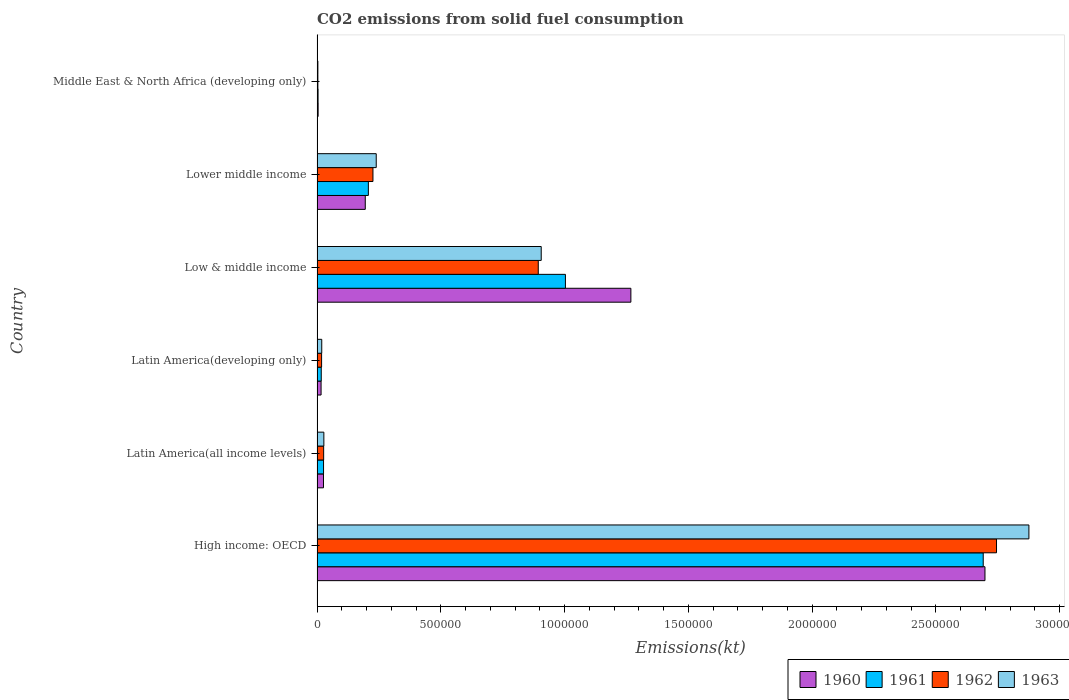How many different coloured bars are there?
Your response must be concise. 4. How many bars are there on the 6th tick from the top?
Offer a terse response. 4. How many bars are there on the 5th tick from the bottom?
Keep it short and to the point. 4. What is the label of the 2nd group of bars from the top?
Keep it short and to the point. Lower middle income. What is the amount of CO2 emitted in 1961 in Middle East & North Africa (developing only)?
Your answer should be very brief. 4102.45. Across all countries, what is the maximum amount of CO2 emitted in 1963?
Give a very brief answer. 2.88e+06. Across all countries, what is the minimum amount of CO2 emitted in 1961?
Your answer should be compact. 4102.45. In which country was the amount of CO2 emitted in 1963 maximum?
Your response must be concise. High income: OECD. In which country was the amount of CO2 emitted in 1963 minimum?
Ensure brevity in your answer.  Middle East & North Africa (developing only). What is the total amount of CO2 emitted in 1960 in the graph?
Your response must be concise. 4.21e+06. What is the difference between the amount of CO2 emitted in 1960 in Latin America(developing only) and that in Middle East & North Africa (developing only)?
Make the answer very short. 1.19e+04. What is the difference between the amount of CO2 emitted in 1960 in High income: OECD and the amount of CO2 emitted in 1963 in Low & middle income?
Keep it short and to the point. 1.79e+06. What is the average amount of CO2 emitted in 1960 per country?
Your answer should be compact. 7.01e+05. What is the difference between the amount of CO2 emitted in 1962 and amount of CO2 emitted in 1960 in Latin America(developing only)?
Ensure brevity in your answer.  2101.12. What is the ratio of the amount of CO2 emitted in 1960 in High income: OECD to that in Latin America(developing only)?
Keep it short and to the point. 166.07. Is the amount of CO2 emitted in 1961 in Low & middle income less than that in Middle East & North Africa (developing only)?
Provide a short and direct response. No. What is the difference between the highest and the second highest amount of CO2 emitted in 1963?
Give a very brief answer. 1.97e+06. What is the difference between the highest and the lowest amount of CO2 emitted in 1962?
Provide a short and direct response. 2.74e+06. In how many countries, is the amount of CO2 emitted in 1960 greater than the average amount of CO2 emitted in 1960 taken over all countries?
Provide a short and direct response. 2. What does the 4th bar from the top in Middle East & North Africa (developing only) represents?
Make the answer very short. 1960. What does the 4th bar from the bottom in Middle East & North Africa (developing only) represents?
Offer a terse response. 1963. Is it the case that in every country, the sum of the amount of CO2 emitted in 1961 and amount of CO2 emitted in 1962 is greater than the amount of CO2 emitted in 1960?
Your answer should be very brief. Yes. How many bars are there?
Your answer should be compact. 24. How many countries are there in the graph?
Provide a short and direct response. 6. What is the difference between two consecutive major ticks on the X-axis?
Your response must be concise. 5.00e+05. Are the values on the major ticks of X-axis written in scientific E-notation?
Offer a terse response. No. Does the graph contain grids?
Ensure brevity in your answer.  No. Where does the legend appear in the graph?
Offer a very short reply. Bottom right. What is the title of the graph?
Make the answer very short. CO2 emissions from solid fuel consumption. What is the label or title of the X-axis?
Your answer should be very brief. Emissions(kt). What is the label or title of the Y-axis?
Keep it short and to the point. Country. What is the Emissions(kt) of 1960 in High income: OECD?
Provide a short and direct response. 2.70e+06. What is the Emissions(kt) of 1961 in High income: OECD?
Your answer should be compact. 2.69e+06. What is the Emissions(kt) in 1962 in High income: OECD?
Offer a terse response. 2.75e+06. What is the Emissions(kt) of 1963 in High income: OECD?
Keep it short and to the point. 2.88e+06. What is the Emissions(kt) in 1960 in Latin America(all income levels)?
Make the answer very short. 2.60e+04. What is the Emissions(kt) of 1961 in Latin America(all income levels)?
Give a very brief answer. 2.63e+04. What is the Emissions(kt) in 1962 in Latin America(all income levels)?
Your response must be concise. 2.67e+04. What is the Emissions(kt) in 1963 in Latin America(all income levels)?
Your answer should be very brief. 2.75e+04. What is the Emissions(kt) in 1960 in Latin America(developing only)?
Make the answer very short. 1.62e+04. What is the Emissions(kt) in 1961 in Latin America(developing only)?
Your response must be concise. 1.70e+04. What is the Emissions(kt) of 1962 in Latin America(developing only)?
Your answer should be very brief. 1.83e+04. What is the Emissions(kt) in 1963 in Latin America(developing only)?
Offer a very short reply. 1.90e+04. What is the Emissions(kt) in 1960 in Low & middle income?
Make the answer very short. 1.27e+06. What is the Emissions(kt) of 1961 in Low & middle income?
Provide a succinct answer. 1.00e+06. What is the Emissions(kt) in 1962 in Low & middle income?
Offer a terse response. 8.94e+05. What is the Emissions(kt) in 1963 in Low & middle income?
Your answer should be very brief. 9.06e+05. What is the Emissions(kt) of 1960 in Lower middle income?
Make the answer very short. 1.95e+05. What is the Emissions(kt) in 1961 in Lower middle income?
Your response must be concise. 2.07e+05. What is the Emissions(kt) of 1962 in Lower middle income?
Give a very brief answer. 2.26e+05. What is the Emissions(kt) of 1963 in Lower middle income?
Make the answer very short. 2.39e+05. What is the Emissions(kt) of 1960 in Middle East & North Africa (developing only)?
Your answer should be very brief. 4356.8. What is the Emissions(kt) of 1961 in Middle East & North Africa (developing only)?
Provide a succinct answer. 4102.45. What is the Emissions(kt) in 1962 in Middle East & North Africa (developing only)?
Your answer should be compact. 3311.16. What is the Emissions(kt) of 1963 in Middle East & North Africa (developing only)?
Your response must be concise. 3301.74. Across all countries, what is the maximum Emissions(kt) in 1960?
Give a very brief answer. 2.70e+06. Across all countries, what is the maximum Emissions(kt) of 1961?
Keep it short and to the point. 2.69e+06. Across all countries, what is the maximum Emissions(kt) of 1962?
Your answer should be very brief. 2.75e+06. Across all countries, what is the maximum Emissions(kt) of 1963?
Offer a terse response. 2.88e+06. Across all countries, what is the minimum Emissions(kt) of 1960?
Keep it short and to the point. 4356.8. Across all countries, what is the minimum Emissions(kt) of 1961?
Keep it short and to the point. 4102.45. Across all countries, what is the minimum Emissions(kt) in 1962?
Offer a terse response. 3311.16. Across all countries, what is the minimum Emissions(kt) in 1963?
Your answer should be very brief. 3301.74. What is the total Emissions(kt) in 1960 in the graph?
Your answer should be very brief. 4.21e+06. What is the total Emissions(kt) in 1961 in the graph?
Ensure brevity in your answer.  3.95e+06. What is the total Emissions(kt) of 1962 in the graph?
Offer a terse response. 3.91e+06. What is the total Emissions(kt) of 1963 in the graph?
Your answer should be compact. 4.07e+06. What is the difference between the Emissions(kt) in 1960 in High income: OECD and that in Latin America(all income levels)?
Make the answer very short. 2.67e+06. What is the difference between the Emissions(kt) of 1961 in High income: OECD and that in Latin America(all income levels)?
Your answer should be very brief. 2.67e+06. What is the difference between the Emissions(kt) of 1962 in High income: OECD and that in Latin America(all income levels)?
Offer a very short reply. 2.72e+06. What is the difference between the Emissions(kt) of 1963 in High income: OECD and that in Latin America(all income levels)?
Offer a terse response. 2.85e+06. What is the difference between the Emissions(kt) of 1960 in High income: OECD and that in Latin America(developing only)?
Give a very brief answer. 2.68e+06. What is the difference between the Emissions(kt) in 1961 in High income: OECD and that in Latin America(developing only)?
Your response must be concise. 2.67e+06. What is the difference between the Emissions(kt) of 1962 in High income: OECD and that in Latin America(developing only)?
Give a very brief answer. 2.73e+06. What is the difference between the Emissions(kt) in 1963 in High income: OECD and that in Latin America(developing only)?
Your answer should be very brief. 2.86e+06. What is the difference between the Emissions(kt) of 1960 in High income: OECD and that in Low & middle income?
Your answer should be very brief. 1.43e+06. What is the difference between the Emissions(kt) in 1961 in High income: OECD and that in Low & middle income?
Ensure brevity in your answer.  1.69e+06. What is the difference between the Emissions(kt) in 1962 in High income: OECD and that in Low & middle income?
Your answer should be compact. 1.85e+06. What is the difference between the Emissions(kt) of 1963 in High income: OECD and that in Low & middle income?
Offer a very short reply. 1.97e+06. What is the difference between the Emissions(kt) in 1960 in High income: OECD and that in Lower middle income?
Your response must be concise. 2.50e+06. What is the difference between the Emissions(kt) of 1961 in High income: OECD and that in Lower middle income?
Offer a terse response. 2.48e+06. What is the difference between the Emissions(kt) of 1962 in High income: OECD and that in Lower middle income?
Keep it short and to the point. 2.52e+06. What is the difference between the Emissions(kt) in 1963 in High income: OECD and that in Lower middle income?
Your answer should be very brief. 2.64e+06. What is the difference between the Emissions(kt) of 1960 in High income: OECD and that in Middle East & North Africa (developing only)?
Offer a very short reply. 2.69e+06. What is the difference between the Emissions(kt) of 1961 in High income: OECD and that in Middle East & North Africa (developing only)?
Provide a short and direct response. 2.69e+06. What is the difference between the Emissions(kt) of 1962 in High income: OECD and that in Middle East & North Africa (developing only)?
Provide a short and direct response. 2.74e+06. What is the difference between the Emissions(kt) of 1963 in High income: OECD and that in Middle East & North Africa (developing only)?
Provide a succinct answer. 2.87e+06. What is the difference between the Emissions(kt) of 1960 in Latin America(all income levels) and that in Latin America(developing only)?
Make the answer very short. 9759.8. What is the difference between the Emissions(kt) of 1961 in Latin America(all income levels) and that in Latin America(developing only)?
Give a very brief answer. 9282.45. What is the difference between the Emissions(kt) in 1962 in Latin America(all income levels) and that in Latin America(developing only)?
Ensure brevity in your answer.  8301.83. What is the difference between the Emissions(kt) of 1963 in Latin America(all income levels) and that in Latin America(developing only)?
Provide a succinct answer. 8542.91. What is the difference between the Emissions(kt) in 1960 in Latin America(all income levels) and that in Low & middle income?
Make the answer very short. -1.24e+06. What is the difference between the Emissions(kt) in 1961 in Latin America(all income levels) and that in Low & middle income?
Your response must be concise. -9.77e+05. What is the difference between the Emissions(kt) of 1962 in Latin America(all income levels) and that in Low & middle income?
Keep it short and to the point. -8.67e+05. What is the difference between the Emissions(kt) of 1963 in Latin America(all income levels) and that in Low & middle income?
Your answer should be very brief. -8.78e+05. What is the difference between the Emissions(kt) of 1960 in Latin America(all income levels) and that in Lower middle income?
Your answer should be compact. -1.69e+05. What is the difference between the Emissions(kt) of 1961 in Latin America(all income levels) and that in Lower middle income?
Provide a succinct answer. -1.81e+05. What is the difference between the Emissions(kt) in 1962 in Latin America(all income levels) and that in Lower middle income?
Keep it short and to the point. -1.99e+05. What is the difference between the Emissions(kt) of 1963 in Latin America(all income levels) and that in Lower middle income?
Provide a succinct answer. -2.12e+05. What is the difference between the Emissions(kt) in 1960 in Latin America(all income levels) and that in Middle East & North Africa (developing only)?
Provide a short and direct response. 2.17e+04. What is the difference between the Emissions(kt) in 1961 in Latin America(all income levels) and that in Middle East & North Africa (developing only)?
Keep it short and to the point. 2.22e+04. What is the difference between the Emissions(kt) in 1962 in Latin America(all income levels) and that in Middle East & North Africa (developing only)?
Keep it short and to the point. 2.33e+04. What is the difference between the Emissions(kt) of 1963 in Latin America(all income levels) and that in Middle East & North Africa (developing only)?
Ensure brevity in your answer.  2.42e+04. What is the difference between the Emissions(kt) in 1960 in Latin America(developing only) and that in Low & middle income?
Your answer should be very brief. -1.25e+06. What is the difference between the Emissions(kt) of 1961 in Latin America(developing only) and that in Low & middle income?
Make the answer very short. -9.86e+05. What is the difference between the Emissions(kt) of 1962 in Latin America(developing only) and that in Low & middle income?
Offer a very short reply. -8.75e+05. What is the difference between the Emissions(kt) of 1963 in Latin America(developing only) and that in Low & middle income?
Keep it short and to the point. -8.87e+05. What is the difference between the Emissions(kt) in 1960 in Latin America(developing only) and that in Lower middle income?
Your response must be concise. -1.79e+05. What is the difference between the Emissions(kt) in 1961 in Latin America(developing only) and that in Lower middle income?
Provide a succinct answer. -1.90e+05. What is the difference between the Emissions(kt) of 1962 in Latin America(developing only) and that in Lower middle income?
Provide a short and direct response. -2.08e+05. What is the difference between the Emissions(kt) in 1963 in Latin America(developing only) and that in Lower middle income?
Your answer should be very brief. -2.20e+05. What is the difference between the Emissions(kt) in 1960 in Latin America(developing only) and that in Middle East & North Africa (developing only)?
Keep it short and to the point. 1.19e+04. What is the difference between the Emissions(kt) of 1961 in Latin America(developing only) and that in Middle East & North Africa (developing only)?
Make the answer very short. 1.29e+04. What is the difference between the Emissions(kt) of 1962 in Latin America(developing only) and that in Middle East & North Africa (developing only)?
Your answer should be very brief. 1.50e+04. What is the difference between the Emissions(kt) in 1963 in Latin America(developing only) and that in Middle East & North Africa (developing only)?
Provide a short and direct response. 1.57e+04. What is the difference between the Emissions(kt) in 1960 in Low & middle income and that in Lower middle income?
Your response must be concise. 1.07e+06. What is the difference between the Emissions(kt) of 1961 in Low & middle income and that in Lower middle income?
Offer a terse response. 7.96e+05. What is the difference between the Emissions(kt) in 1962 in Low & middle income and that in Lower middle income?
Offer a terse response. 6.68e+05. What is the difference between the Emissions(kt) of 1963 in Low & middle income and that in Lower middle income?
Provide a short and direct response. 6.67e+05. What is the difference between the Emissions(kt) in 1960 in Low & middle income and that in Middle East & North Africa (developing only)?
Provide a short and direct response. 1.26e+06. What is the difference between the Emissions(kt) of 1961 in Low & middle income and that in Middle East & North Africa (developing only)?
Provide a succinct answer. 9.99e+05. What is the difference between the Emissions(kt) in 1962 in Low & middle income and that in Middle East & North Africa (developing only)?
Your response must be concise. 8.90e+05. What is the difference between the Emissions(kt) of 1963 in Low & middle income and that in Middle East & North Africa (developing only)?
Offer a very short reply. 9.02e+05. What is the difference between the Emissions(kt) in 1960 in Lower middle income and that in Middle East & North Africa (developing only)?
Provide a short and direct response. 1.90e+05. What is the difference between the Emissions(kt) in 1961 in Lower middle income and that in Middle East & North Africa (developing only)?
Your answer should be compact. 2.03e+05. What is the difference between the Emissions(kt) of 1962 in Lower middle income and that in Middle East & North Africa (developing only)?
Provide a short and direct response. 2.23e+05. What is the difference between the Emissions(kt) in 1963 in Lower middle income and that in Middle East & North Africa (developing only)?
Your response must be concise. 2.36e+05. What is the difference between the Emissions(kt) in 1960 in High income: OECD and the Emissions(kt) in 1961 in Latin America(all income levels)?
Ensure brevity in your answer.  2.67e+06. What is the difference between the Emissions(kt) in 1960 in High income: OECD and the Emissions(kt) in 1962 in Latin America(all income levels)?
Provide a short and direct response. 2.67e+06. What is the difference between the Emissions(kt) of 1960 in High income: OECD and the Emissions(kt) of 1963 in Latin America(all income levels)?
Keep it short and to the point. 2.67e+06. What is the difference between the Emissions(kt) of 1961 in High income: OECD and the Emissions(kt) of 1962 in Latin America(all income levels)?
Make the answer very short. 2.66e+06. What is the difference between the Emissions(kt) of 1961 in High income: OECD and the Emissions(kt) of 1963 in Latin America(all income levels)?
Keep it short and to the point. 2.66e+06. What is the difference between the Emissions(kt) of 1962 in High income: OECD and the Emissions(kt) of 1963 in Latin America(all income levels)?
Ensure brevity in your answer.  2.72e+06. What is the difference between the Emissions(kt) of 1960 in High income: OECD and the Emissions(kt) of 1961 in Latin America(developing only)?
Provide a succinct answer. 2.68e+06. What is the difference between the Emissions(kt) of 1960 in High income: OECD and the Emissions(kt) of 1962 in Latin America(developing only)?
Ensure brevity in your answer.  2.68e+06. What is the difference between the Emissions(kt) of 1960 in High income: OECD and the Emissions(kt) of 1963 in Latin America(developing only)?
Your answer should be very brief. 2.68e+06. What is the difference between the Emissions(kt) in 1961 in High income: OECD and the Emissions(kt) in 1962 in Latin America(developing only)?
Offer a very short reply. 2.67e+06. What is the difference between the Emissions(kt) in 1961 in High income: OECD and the Emissions(kt) in 1963 in Latin America(developing only)?
Your answer should be compact. 2.67e+06. What is the difference between the Emissions(kt) in 1962 in High income: OECD and the Emissions(kt) in 1963 in Latin America(developing only)?
Ensure brevity in your answer.  2.73e+06. What is the difference between the Emissions(kt) of 1960 in High income: OECD and the Emissions(kt) of 1961 in Low & middle income?
Ensure brevity in your answer.  1.69e+06. What is the difference between the Emissions(kt) of 1960 in High income: OECD and the Emissions(kt) of 1962 in Low & middle income?
Offer a very short reply. 1.80e+06. What is the difference between the Emissions(kt) of 1960 in High income: OECD and the Emissions(kt) of 1963 in Low & middle income?
Give a very brief answer. 1.79e+06. What is the difference between the Emissions(kt) of 1961 in High income: OECD and the Emissions(kt) of 1962 in Low & middle income?
Give a very brief answer. 1.80e+06. What is the difference between the Emissions(kt) of 1961 in High income: OECD and the Emissions(kt) of 1963 in Low & middle income?
Provide a succinct answer. 1.79e+06. What is the difference between the Emissions(kt) in 1962 in High income: OECD and the Emissions(kt) in 1963 in Low & middle income?
Provide a short and direct response. 1.84e+06. What is the difference between the Emissions(kt) of 1960 in High income: OECD and the Emissions(kt) of 1961 in Lower middle income?
Offer a very short reply. 2.49e+06. What is the difference between the Emissions(kt) in 1960 in High income: OECD and the Emissions(kt) in 1962 in Lower middle income?
Ensure brevity in your answer.  2.47e+06. What is the difference between the Emissions(kt) in 1960 in High income: OECD and the Emissions(kt) in 1963 in Lower middle income?
Provide a succinct answer. 2.46e+06. What is the difference between the Emissions(kt) of 1961 in High income: OECD and the Emissions(kt) of 1962 in Lower middle income?
Ensure brevity in your answer.  2.47e+06. What is the difference between the Emissions(kt) in 1961 in High income: OECD and the Emissions(kt) in 1963 in Lower middle income?
Your response must be concise. 2.45e+06. What is the difference between the Emissions(kt) in 1962 in High income: OECD and the Emissions(kt) in 1963 in Lower middle income?
Provide a short and direct response. 2.51e+06. What is the difference between the Emissions(kt) in 1960 in High income: OECD and the Emissions(kt) in 1961 in Middle East & North Africa (developing only)?
Provide a short and direct response. 2.69e+06. What is the difference between the Emissions(kt) of 1960 in High income: OECD and the Emissions(kt) of 1962 in Middle East & North Africa (developing only)?
Your answer should be very brief. 2.70e+06. What is the difference between the Emissions(kt) in 1960 in High income: OECD and the Emissions(kt) in 1963 in Middle East & North Africa (developing only)?
Offer a very short reply. 2.70e+06. What is the difference between the Emissions(kt) of 1961 in High income: OECD and the Emissions(kt) of 1962 in Middle East & North Africa (developing only)?
Your answer should be very brief. 2.69e+06. What is the difference between the Emissions(kt) in 1961 in High income: OECD and the Emissions(kt) in 1963 in Middle East & North Africa (developing only)?
Give a very brief answer. 2.69e+06. What is the difference between the Emissions(kt) in 1962 in High income: OECD and the Emissions(kt) in 1963 in Middle East & North Africa (developing only)?
Offer a very short reply. 2.74e+06. What is the difference between the Emissions(kt) of 1960 in Latin America(all income levels) and the Emissions(kt) of 1961 in Latin America(developing only)?
Give a very brief answer. 9031.46. What is the difference between the Emissions(kt) of 1960 in Latin America(all income levels) and the Emissions(kt) of 1962 in Latin America(developing only)?
Make the answer very short. 7658.68. What is the difference between the Emissions(kt) in 1960 in Latin America(all income levels) and the Emissions(kt) in 1963 in Latin America(developing only)?
Provide a succinct answer. 7040.93. What is the difference between the Emissions(kt) in 1961 in Latin America(all income levels) and the Emissions(kt) in 1962 in Latin America(developing only)?
Your answer should be compact. 7909.66. What is the difference between the Emissions(kt) of 1961 in Latin America(all income levels) and the Emissions(kt) of 1963 in Latin America(developing only)?
Offer a very short reply. 7291.91. What is the difference between the Emissions(kt) of 1962 in Latin America(all income levels) and the Emissions(kt) of 1963 in Latin America(developing only)?
Offer a terse response. 7684.07. What is the difference between the Emissions(kt) of 1960 in Latin America(all income levels) and the Emissions(kt) of 1961 in Low & middle income?
Keep it short and to the point. -9.77e+05. What is the difference between the Emissions(kt) of 1960 in Latin America(all income levels) and the Emissions(kt) of 1962 in Low & middle income?
Make the answer very short. -8.68e+05. What is the difference between the Emissions(kt) in 1960 in Latin America(all income levels) and the Emissions(kt) in 1963 in Low & middle income?
Offer a terse response. -8.80e+05. What is the difference between the Emissions(kt) in 1961 in Latin America(all income levels) and the Emissions(kt) in 1962 in Low & middle income?
Keep it short and to the point. -8.67e+05. What is the difference between the Emissions(kt) of 1961 in Latin America(all income levels) and the Emissions(kt) of 1963 in Low & middle income?
Provide a short and direct response. -8.79e+05. What is the difference between the Emissions(kt) in 1962 in Latin America(all income levels) and the Emissions(kt) in 1963 in Low & middle income?
Provide a short and direct response. -8.79e+05. What is the difference between the Emissions(kt) in 1960 in Latin America(all income levels) and the Emissions(kt) in 1961 in Lower middle income?
Your answer should be very brief. -1.81e+05. What is the difference between the Emissions(kt) of 1960 in Latin America(all income levels) and the Emissions(kt) of 1962 in Lower middle income?
Give a very brief answer. -2.00e+05. What is the difference between the Emissions(kt) in 1960 in Latin America(all income levels) and the Emissions(kt) in 1963 in Lower middle income?
Your response must be concise. -2.13e+05. What is the difference between the Emissions(kt) in 1961 in Latin America(all income levels) and the Emissions(kt) in 1962 in Lower middle income?
Make the answer very short. -2.00e+05. What is the difference between the Emissions(kt) of 1961 in Latin America(all income levels) and the Emissions(kt) of 1963 in Lower middle income?
Give a very brief answer. -2.13e+05. What is the difference between the Emissions(kt) of 1962 in Latin America(all income levels) and the Emissions(kt) of 1963 in Lower middle income?
Make the answer very short. -2.12e+05. What is the difference between the Emissions(kt) in 1960 in Latin America(all income levels) and the Emissions(kt) in 1961 in Middle East & North Africa (developing only)?
Make the answer very short. 2.19e+04. What is the difference between the Emissions(kt) in 1960 in Latin America(all income levels) and the Emissions(kt) in 1962 in Middle East & North Africa (developing only)?
Your response must be concise. 2.27e+04. What is the difference between the Emissions(kt) in 1960 in Latin America(all income levels) and the Emissions(kt) in 1963 in Middle East & North Africa (developing only)?
Make the answer very short. 2.27e+04. What is the difference between the Emissions(kt) in 1961 in Latin America(all income levels) and the Emissions(kt) in 1962 in Middle East & North Africa (developing only)?
Your answer should be very brief. 2.29e+04. What is the difference between the Emissions(kt) of 1961 in Latin America(all income levels) and the Emissions(kt) of 1963 in Middle East & North Africa (developing only)?
Provide a succinct answer. 2.30e+04. What is the difference between the Emissions(kt) of 1962 in Latin America(all income levels) and the Emissions(kt) of 1963 in Middle East & North Africa (developing only)?
Ensure brevity in your answer.  2.33e+04. What is the difference between the Emissions(kt) of 1960 in Latin America(developing only) and the Emissions(kt) of 1961 in Low & middle income?
Provide a short and direct response. -9.87e+05. What is the difference between the Emissions(kt) of 1960 in Latin America(developing only) and the Emissions(kt) of 1962 in Low & middle income?
Provide a succinct answer. -8.77e+05. What is the difference between the Emissions(kt) in 1960 in Latin America(developing only) and the Emissions(kt) in 1963 in Low & middle income?
Your response must be concise. -8.89e+05. What is the difference between the Emissions(kt) of 1961 in Latin America(developing only) and the Emissions(kt) of 1962 in Low & middle income?
Provide a short and direct response. -8.77e+05. What is the difference between the Emissions(kt) in 1961 in Latin America(developing only) and the Emissions(kt) in 1963 in Low & middle income?
Give a very brief answer. -8.89e+05. What is the difference between the Emissions(kt) of 1962 in Latin America(developing only) and the Emissions(kt) of 1963 in Low & middle income?
Your response must be concise. -8.87e+05. What is the difference between the Emissions(kt) in 1960 in Latin America(developing only) and the Emissions(kt) in 1961 in Lower middle income?
Provide a succinct answer. -1.91e+05. What is the difference between the Emissions(kt) of 1960 in Latin America(developing only) and the Emissions(kt) of 1962 in Lower middle income?
Provide a short and direct response. -2.10e+05. What is the difference between the Emissions(kt) of 1960 in Latin America(developing only) and the Emissions(kt) of 1963 in Lower middle income?
Your response must be concise. -2.23e+05. What is the difference between the Emissions(kt) of 1961 in Latin America(developing only) and the Emissions(kt) of 1962 in Lower middle income?
Provide a short and direct response. -2.09e+05. What is the difference between the Emissions(kt) of 1961 in Latin America(developing only) and the Emissions(kt) of 1963 in Lower middle income?
Give a very brief answer. -2.22e+05. What is the difference between the Emissions(kt) in 1962 in Latin America(developing only) and the Emissions(kt) in 1963 in Lower middle income?
Offer a terse response. -2.21e+05. What is the difference between the Emissions(kt) in 1960 in Latin America(developing only) and the Emissions(kt) in 1961 in Middle East & North Africa (developing only)?
Offer a very short reply. 1.21e+04. What is the difference between the Emissions(kt) in 1960 in Latin America(developing only) and the Emissions(kt) in 1962 in Middle East & North Africa (developing only)?
Keep it short and to the point. 1.29e+04. What is the difference between the Emissions(kt) in 1960 in Latin America(developing only) and the Emissions(kt) in 1963 in Middle East & North Africa (developing only)?
Offer a very short reply. 1.29e+04. What is the difference between the Emissions(kt) of 1961 in Latin America(developing only) and the Emissions(kt) of 1962 in Middle East & North Africa (developing only)?
Ensure brevity in your answer.  1.37e+04. What is the difference between the Emissions(kt) of 1961 in Latin America(developing only) and the Emissions(kt) of 1963 in Middle East & North Africa (developing only)?
Offer a very short reply. 1.37e+04. What is the difference between the Emissions(kt) of 1962 in Latin America(developing only) and the Emissions(kt) of 1963 in Middle East & North Africa (developing only)?
Your answer should be very brief. 1.50e+04. What is the difference between the Emissions(kt) of 1960 in Low & middle income and the Emissions(kt) of 1961 in Lower middle income?
Your answer should be very brief. 1.06e+06. What is the difference between the Emissions(kt) in 1960 in Low & middle income and the Emissions(kt) in 1962 in Lower middle income?
Offer a very short reply. 1.04e+06. What is the difference between the Emissions(kt) in 1960 in Low & middle income and the Emissions(kt) in 1963 in Lower middle income?
Offer a terse response. 1.03e+06. What is the difference between the Emissions(kt) in 1961 in Low & middle income and the Emissions(kt) in 1962 in Lower middle income?
Ensure brevity in your answer.  7.78e+05. What is the difference between the Emissions(kt) in 1961 in Low & middle income and the Emissions(kt) in 1963 in Lower middle income?
Ensure brevity in your answer.  7.64e+05. What is the difference between the Emissions(kt) in 1962 in Low & middle income and the Emissions(kt) in 1963 in Lower middle income?
Your response must be concise. 6.55e+05. What is the difference between the Emissions(kt) of 1960 in Low & middle income and the Emissions(kt) of 1961 in Middle East & North Africa (developing only)?
Keep it short and to the point. 1.26e+06. What is the difference between the Emissions(kt) of 1960 in Low & middle income and the Emissions(kt) of 1962 in Middle East & North Africa (developing only)?
Your answer should be very brief. 1.26e+06. What is the difference between the Emissions(kt) of 1960 in Low & middle income and the Emissions(kt) of 1963 in Middle East & North Africa (developing only)?
Provide a succinct answer. 1.26e+06. What is the difference between the Emissions(kt) of 1961 in Low & middle income and the Emissions(kt) of 1962 in Middle East & North Africa (developing only)?
Offer a very short reply. 1.00e+06. What is the difference between the Emissions(kt) of 1961 in Low & middle income and the Emissions(kt) of 1963 in Middle East & North Africa (developing only)?
Give a very brief answer. 1.00e+06. What is the difference between the Emissions(kt) in 1962 in Low & middle income and the Emissions(kt) in 1963 in Middle East & North Africa (developing only)?
Offer a terse response. 8.90e+05. What is the difference between the Emissions(kt) of 1960 in Lower middle income and the Emissions(kt) of 1961 in Middle East & North Africa (developing only)?
Offer a terse response. 1.91e+05. What is the difference between the Emissions(kt) of 1960 in Lower middle income and the Emissions(kt) of 1962 in Middle East & North Africa (developing only)?
Offer a very short reply. 1.91e+05. What is the difference between the Emissions(kt) in 1960 in Lower middle income and the Emissions(kt) in 1963 in Middle East & North Africa (developing only)?
Your answer should be compact. 1.92e+05. What is the difference between the Emissions(kt) in 1961 in Lower middle income and the Emissions(kt) in 1962 in Middle East & North Africa (developing only)?
Offer a terse response. 2.04e+05. What is the difference between the Emissions(kt) of 1961 in Lower middle income and the Emissions(kt) of 1963 in Middle East & North Africa (developing only)?
Provide a succinct answer. 2.04e+05. What is the difference between the Emissions(kt) in 1962 in Lower middle income and the Emissions(kt) in 1963 in Middle East & North Africa (developing only)?
Your answer should be compact. 2.23e+05. What is the average Emissions(kt) in 1960 per country?
Provide a succinct answer. 7.01e+05. What is the average Emissions(kt) in 1961 per country?
Your answer should be very brief. 6.58e+05. What is the average Emissions(kt) in 1962 per country?
Keep it short and to the point. 6.52e+05. What is the average Emissions(kt) in 1963 per country?
Your answer should be compact. 6.78e+05. What is the difference between the Emissions(kt) in 1960 and Emissions(kt) in 1961 in High income: OECD?
Offer a very short reply. 7090.26. What is the difference between the Emissions(kt) in 1960 and Emissions(kt) in 1962 in High income: OECD?
Give a very brief answer. -4.67e+04. What is the difference between the Emissions(kt) in 1960 and Emissions(kt) in 1963 in High income: OECD?
Your answer should be very brief. -1.77e+05. What is the difference between the Emissions(kt) of 1961 and Emissions(kt) of 1962 in High income: OECD?
Offer a very short reply. -5.38e+04. What is the difference between the Emissions(kt) of 1961 and Emissions(kt) of 1963 in High income: OECD?
Ensure brevity in your answer.  -1.85e+05. What is the difference between the Emissions(kt) of 1962 and Emissions(kt) of 1963 in High income: OECD?
Give a very brief answer. -1.31e+05. What is the difference between the Emissions(kt) in 1960 and Emissions(kt) in 1961 in Latin America(all income levels)?
Provide a short and direct response. -250.98. What is the difference between the Emissions(kt) in 1960 and Emissions(kt) in 1962 in Latin America(all income levels)?
Provide a short and direct response. -643.15. What is the difference between the Emissions(kt) of 1960 and Emissions(kt) of 1963 in Latin America(all income levels)?
Keep it short and to the point. -1501.98. What is the difference between the Emissions(kt) in 1961 and Emissions(kt) in 1962 in Latin America(all income levels)?
Your response must be concise. -392.16. What is the difference between the Emissions(kt) in 1961 and Emissions(kt) in 1963 in Latin America(all income levels)?
Ensure brevity in your answer.  -1251. What is the difference between the Emissions(kt) of 1962 and Emissions(kt) of 1963 in Latin America(all income levels)?
Provide a succinct answer. -858.84. What is the difference between the Emissions(kt) in 1960 and Emissions(kt) in 1961 in Latin America(developing only)?
Your answer should be very brief. -728.34. What is the difference between the Emissions(kt) in 1960 and Emissions(kt) in 1962 in Latin America(developing only)?
Make the answer very short. -2101.12. What is the difference between the Emissions(kt) in 1960 and Emissions(kt) in 1963 in Latin America(developing only)?
Provide a succinct answer. -2718.88. What is the difference between the Emissions(kt) in 1961 and Emissions(kt) in 1962 in Latin America(developing only)?
Ensure brevity in your answer.  -1372.79. What is the difference between the Emissions(kt) in 1961 and Emissions(kt) in 1963 in Latin America(developing only)?
Your answer should be very brief. -1990.54. What is the difference between the Emissions(kt) in 1962 and Emissions(kt) in 1963 in Latin America(developing only)?
Give a very brief answer. -617.75. What is the difference between the Emissions(kt) of 1960 and Emissions(kt) of 1961 in Low & middle income?
Your response must be concise. 2.64e+05. What is the difference between the Emissions(kt) in 1960 and Emissions(kt) in 1962 in Low & middle income?
Make the answer very short. 3.74e+05. What is the difference between the Emissions(kt) in 1960 and Emissions(kt) in 1963 in Low & middle income?
Your answer should be compact. 3.62e+05. What is the difference between the Emissions(kt) of 1961 and Emissions(kt) of 1962 in Low & middle income?
Offer a very short reply. 1.10e+05. What is the difference between the Emissions(kt) in 1961 and Emissions(kt) in 1963 in Low & middle income?
Provide a succinct answer. 9.78e+04. What is the difference between the Emissions(kt) of 1962 and Emissions(kt) of 1963 in Low & middle income?
Your response must be concise. -1.20e+04. What is the difference between the Emissions(kt) in 1960 and Emissions(kt) in 1961 in Lower middle income?
Keep it short and to the point. -1.25e+04. What is the difference between the Emissions(kt) in 1960 and Emissions(kt) in 1962 in Lower middle income?
Provide a short and direct response. -3.10e+04. What is the difference between the Emissions(kt) of 1960 and Emissions(kt) of 1963 in Lower middle income?
Your answer should be very brief. -4.43e+04. What is the difference between the Emissions(kt) of 1961 and Emissions(kt) of 1962 in Lower middle income?
Offer a terse response. -1.86e+04. What is the difference between the Emissions(kt) in 1961 and Emissions(kt) in 1963 in Lower middle income?
Your answer should be compact. -3.18e+04. What is the difference between the Emissions(kt) of 1962 and Emissions(kt) of 1963 in Lower middle income?
Provide a succinct answer. -1.32e+04. What is the difference between the Emissions(kt) in 1960 and Emissions(kt) in 1961 in Middle East & North Africa (developing only)?
Your answer should be compact. 254.34. What is the difference between the Emissions(kt) of 1960 and Emissions(kt) of 1962 in Middle East & North Africa (developing only)?
Give a very brief answer. 1045.63. What is the difference between the Emissions(kt) in 1960 and Emissions(kt) in 1963 in Middle East & North Africa (developing only)?
Provide a succinct answer. 1055.05. What is the difference between the Emissions(kt) of 1961 and Emissions(kt) of 1962 in Middle East & North Africa (developing only)?
Ensure brevity in your answer.  791.29. What is the difference between the Emissions(kt) in 1961 and Emissions(kt) in 1963 in Middle East & North Africa (developing only)?
Your answer should be compact. 800.71. What is the difference between the Emissions(kt) in 1962 and Emissions(kt) in 1963 in Middle East & North Africa (developing only)?
Your response must be concise. 9.42. What is the ratio of the Emissions(kt) in 1960 in High income: OECD to that in Latin America(all income levels)?
Provide a short and direct response. 103.75. What is the ratio of the Emissions(kt) of 1961 in High income: OECD to that in Latin America(all income levels)?
Provide a short and direct response. 102.49. What is the ratio of the Emissions(kt) in 1962 in High income: OECD to that in Latin America(all income levels)?
Give a very brief answer. 103. What is the ratio of the Emissions(kt) of 1963 in High income: OECD to that in Latin America(all income levels)?
Offer a very short reply. 104.54. What is the ratio of the Emissions(kt) in 1960 in High income: OECD to that in Latin America(developing only)?
Keep it short and to the point. 166.07. What is the ratio of the Emissions(kt) of 1961 in High income: OECD to that in Latin America(developing only)?
Keep it short and to the point. 158.53. What is the ratio of the Emissions(kt) in 1962 in High income: OECD to that in Latin America(developing only)?
Give a very brief answer. 149.6. What is the ratio of the Emissions(kt) of 1963 in High income: OECD to that in Latin America(developing only)?
Your answer should be compact. 151.62. What is the ratio of the Emissions(kt) of 1960 in High income: OECD to that in Low & middle income?
Your response must be concise. 2.13. What is the ratio of the Emissions(kt) in 1961 in High income: OECD to that in Low & middle income?
Offer a terse response. 2.68. What is the ratio of the Emissions(kt) in 1962 in High income: OECD to that in Low & middle income?
Give a very brief answer. 3.07. What is the ratio of the Emissions(kt) in 1963 in High income: OECD to that in Low & middle income?
Make the answer very short. 3.18. What is the ratio of the Emissions(kt) in 1960 in High income: OECD to that in Lower middle income?
Your answer should be compact. 13.85. What is the ratio of the Emissions(kt) of 1961 in High income: OECD to that in Lower middle income?
Provide a short and direct response. 12.98. What is the ratio of the Emissions(kt) in 1962 in High income: OECD to that in Lower middle income?
Ensure brevity in your answer.  12.15. What is the ratio of the Emissions(kt) of 1963 in High income: OECD to that in Lower middle income?
Provide a short and direct response. 12.03. What is the ratio of the Emissions(kt) of 1960 in High income: OECD to that in Middle East & North Africa (developing only)?
Provide a short and direct response. 619.35. What is the ratio of the Emissions(kt) in 1961 in High income: OECD to that in Middle East & North Africa (developing only)?
Your answer should be very brief. 656.02. What is the ratio of the Emissions(kt) in 1962 in High income: OECD to that in Middle East & North Africa (developing only)?
Provide a short and direct response. 829.03. What is the ratio of the Emissions(kt) in 1963 in High income: OECD to that in Middle East & North Africa (developing only)?
Keep it short and to the point. 871.02. What is the ratio of the Emissions(kt) in 1960 in Latin America(all income levels) to that in Latin America(developing only)?
Your answer should be compact. 1.6. What is the ratio of the Emissions(kt) in 1961 in Latin America(all income levels) to that in Latin America(developing only)?
Offer a very short reply. 1.55. What is the ratio of the Emissions(kt) in 1962 in Latin America(all income levels) to that in Latin America(developing only)?
Offer a very short reply. 1.45. What is the ratio of the Emissions(kt) of 1963 in Latin America(all income levels) to that in Latin America(developing only)?
Provide a succinct answer. 1.45. What is the ratio of the Emissions(kt) of 1960 in Latin America(all income levels) to that in Low & middle income?
Provide a succinct answer. 0.02. What is the ratio of the Emissions(kt) of 1961 in Latin America(all income levels) to that in Low & middle income?
Your answer should be very brief. 0.03. What is the ratio of the Emissions(kt) in 1962 in Latin America(all income levels) to that in Low & middle income?
Offer a very short reply. 0.03. What is the ratio of the Emissions(kt) of 1963 in Latin America(all income levels) to that in Low & middle income?
Provide a succinct answer. 0.03. What is the ratio of the Emissions(kt) in 1960 in Latin America(all income levels) to that in Lower middle income?
Your response must be concise. 0.13. What is the ratio of the Emissions(kt) in 1961 in Latin America(all income levels) to that in Lower middle income?
Provide a succinct answer. 0.13. What is the ratio of the Emissions(kt) of 1962 in Latin America(all income levels) to that in Lower middle income?
Keep it short and to the point. 0.12. What is the ratio of the Emissions(kt) of 1963 in Latin America(all income levels) to that in Lower middle income?
Your answer should be very brief. 0.12. What is the ratio of the Emissions(kt) in 1960 in Latin America(all income levels) to that in Middle East & North Africa (developing only)?
Ensure brevity in your answer.  5.97. What is the ratio of the Emissions(kt) of 1961 in Latin America(all income levels) to that in Middle East & North Africa (developing only)?
Offer a very short reply. 6.4. What is the ratio of the Emissions(kt) in 1962 in Latin America(all income levels) to that in Middle East & North Africa (developing only)?
Make the answer very short. 8.05. What is the ratio of the Emissions(kt) of 1963 in Latin America(all income levels) to that in Middle East & North Africa (developing only)?
Your response must be concise. 8.33. What is the ratio of the Emissions(kt) of 1960 in Latin America(developing only) to that in Low & middle income?
Your answer should be compact. 0.01. What is the ratio of the Emissions(kt) in 1961 in Latin America(developing only) to that in Low & middle income?
Provide a short and direct response. 0.02. What is the ratio of the Emissions(kt) of 1962 in Latin America(developing only) to that in Low & middle income?
Your answer should be compact. 0.02. What is the ratio of the Emissions(kt) in 1963 in Latin America(developing only) to that in Low & middle income?
Make the answer very short. 0.02. What is the ratio of the Emissions(kt) of 1960 in Latin America(developing only) to that in Lower middle income?
Give a very brief answer. 0.08. What is the ratio of the Emissions(kt) of 1961 in Latin America(developing only) to that in Lower middle income?
Offer a very short reply. 0.08. What is the ratio of the Emissions(kt) in 1962 in Latin America(developing only) to that in Lower middle income?
Keep it short and to the point. 0.08. What is the ratio of the Emissions(kt) of 1963 in Latin America(developing only) to that in Lower middle income?
Provide a short and direct response. 0.08. What is the ratio of the Emissions(kt) of 1960 in Latin America(developing only) to that in Middle East & North Africa (developing only)?
Your response must be concise. 3.73. What is the ratio of the Emissions(kt) of 1961 in Latin America(developing only) to that in Middle East & North Africa (developing only)?
Offer a very short reply. 4.14. What is the ratio of the Emissions(kt) of 1962 in Latin America(developing only) to that in Middle East & North Africa (developing only)?
Provide a short and direct response. 5.54. What is the ratio of the Emissions(kt) in 1963 in Latin America(developing only) to that in Middle East & North Africa (developing only)?
Your response must be concise. 5.74. What is the ratio of the Emissions(kt) in 1960 in Low & middle income to that in Lower middle income?
Offer a terse response. 6.51. What is the ratio of the Emissions(kt) of 1961 in Low & middle income to that in Lower middle income?
Give a very brief answer. 4.84. What is the ratio of the Emissions(kt) of 1962 in Low & middle income to that in Lower middle income?
Offer a terse response. 3.96. What is the ratio of the Emissions(kt) in 1963 in Low & middle income to that in Lower middle income?
Your answer should be compact. 3.79. What is the ratio of the Emissions(kt) in 1960 in Low & middle income to that in Middle East & North Africa (developing only)?
Offer a very short reply. 291. What is the ratio of the Emissions(kt) in 1961 in Low & middle income to that in Middle East & North Africa (developing only)?
Your answer should be very brief. 244.6. What is the ratio of the Emissions(kt) of 1962 in Low & middle income to that in Middle East & North Africa (developing only)?
Your response must be concise. 269.9. What is the ratio of the Emissions(kt) of 1963 in Low & middle income to that in Middle East & North Africa (developing only)?
Provide a succinct answer. 274.29. What is the ratio of the Emissions(kt) of 1960 in Lower middle income to that in Middle East & North Africa (developing only)?
Provide a short and direct response. 44.71. What is the ratio of the Emissions(kt) in 1961 in Lower middle income to that in Middle East & North Africa (developing only)?
Your answer should be compact. 50.53. What is the ratio of the Emissions(kt) in 1962 in Lower middle income to that in Middle East & North Africa (developing only)?
Make the answer very short. 68.21. What is the ratio of the Emissions(kt) in 1963 in Lower middle income to that in Middle East & North Africa (developing only)?
Your answer should be very brief. 72.42. What is the difference between the highest and the second highest Emissions(kt) of 1960?
Offer a very short reply. 1.43e+06. What is the difference between the highest and the second highest Emissions(kt) of 1961?
Offer a very short reply. 1.69e+06. What is the difference between the highest and the second highest Emissions(kt) of 1962?
Provide a short and direct response. 1.85e+06. What is the difference between the highest and the second highest Emissions(kt) in 1963?
Provide a succinct answer. 1.97e+06. What is the difference between the highest and the lowest Emissions(kt) in 1960?
Your answer should be compact. 2.69e+06. What is the difference between the highest and the lowest Emissions(kt) of 1961?
Keep it short and to the point. 2.69e+06. What is the difference between the highest and the lowest Emissions(kt) of 1962?
Ensure brevity in your answer.  2.74e+06. What is the difference between the highest and the lowest Emissions(kt) of 1963?
Your answer should be very brief. 2.87e+06. 